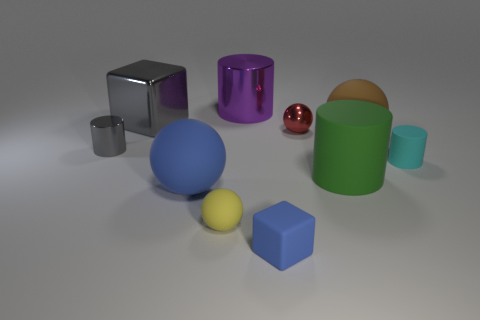Do the shiny cube and the tiny shiny cylinder have the same color?
Ensure brevity in your answer.  Yes. There is a big ball on the right side of the large object that is behind the gray object to the right of the small gray cylinder; what is its color?
Offer a very short reply. Brown. What material is the purple cylinder that is the same size as the blue rubber ball?
Offer a very short reply. Metal. What number of things are shiny cylinders that are in front of the big gray object or big brown rubber things?
Give a very brief answer. 2. Is there a purple cube?
Provide a short and direct response. No. What is the blue thing to the left of the purple object made of?
Your answer should be very brief. Rubber. There is a tiny thing that is the same color as the big cube; what is it made of?
Provide a short and direct response. Metal. What number of tiny objects are either gray blocks or red metallic cylinders?
Make the answer very short. 0. The tiny matte ball has what color?
Offer a very short reply. Yellow. There is a gray thing in front of the large brown object; is there a object behind it?
Ensure brevity in your answer.  Yes. 